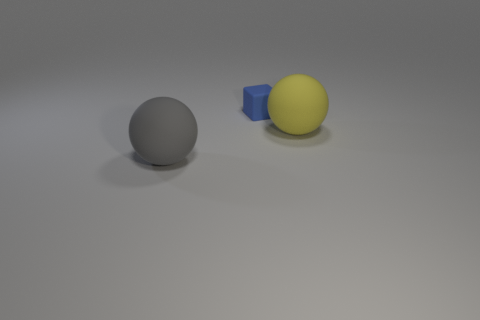Is the number of small blue things that are on the right side of the tiny rubber thing less than the number of yellow spheres?
Provide a succinct answer. Yes. There is a matte sphere behind the gray matte object; is its size the same as the blue cube?
Provide a short and direct response. No. How many objects are both behind the yellow rubber object and left of the tiny blue cube?
Make the answer very short. 0. What is the size of the ball that is to the right of the big object that is left of the tiny blue block?
Offer a terse response. Large. Are there fewer blue objects that are on the left side of the gray object than big yellow matte things behind the tiny thing?
Your answer should be compact. No. There is a matte object that is behind the yellow ball; is it the same color as the large rubber thing that is left of the yellow object?
Provide a short and direct response. No. There is a thing that is in front of the blue rubber object and on the left side of the yellow thing; what is its material?
Your answer should be very brief. Rubber. Is there a green matte block?
Offer a terse response. No. There is a small blue object that is the same material as the yellow object; what is its shape?
Your answer should be compact. Cube. There is a large gray thing; is its shape the same as the small matte object that is on the left side of the large yellow thing?
Provide a succinct answer. No. 